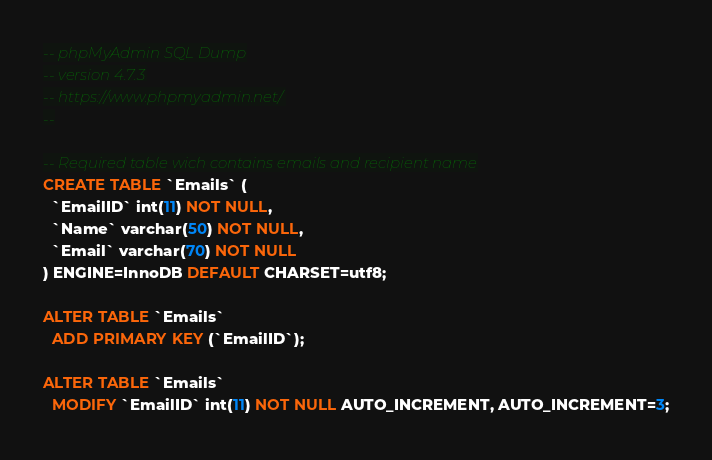Convert code to text. <code><loc_0><loc_0><loc_500><loc_500><_SQL_>-- phpMyAdmin SQL Dump
-- version 4.7.3
-- https://www.phpmyadmin.net/
--

-- Required table wich contains emails and recipient name
CREATE TABLE `Emails` (
  `EmailID` int(11) NOT NULL,
  `Name` varchar(50) NOT NULL,
  `Email` varchar(70) NOT NULL
) ENGINE=InnoDB DEFAULT CHARSET=utf8;

ALTER TABLE `Emails`
  ADD PRIMARY KEY (`EmailID`);

ALTER TABLE `Emails`
  MODIFY `EmailID` int(11) NOT NULL AUTO_INCREMENT, AUTO_INCREMENT=3;


</code> 